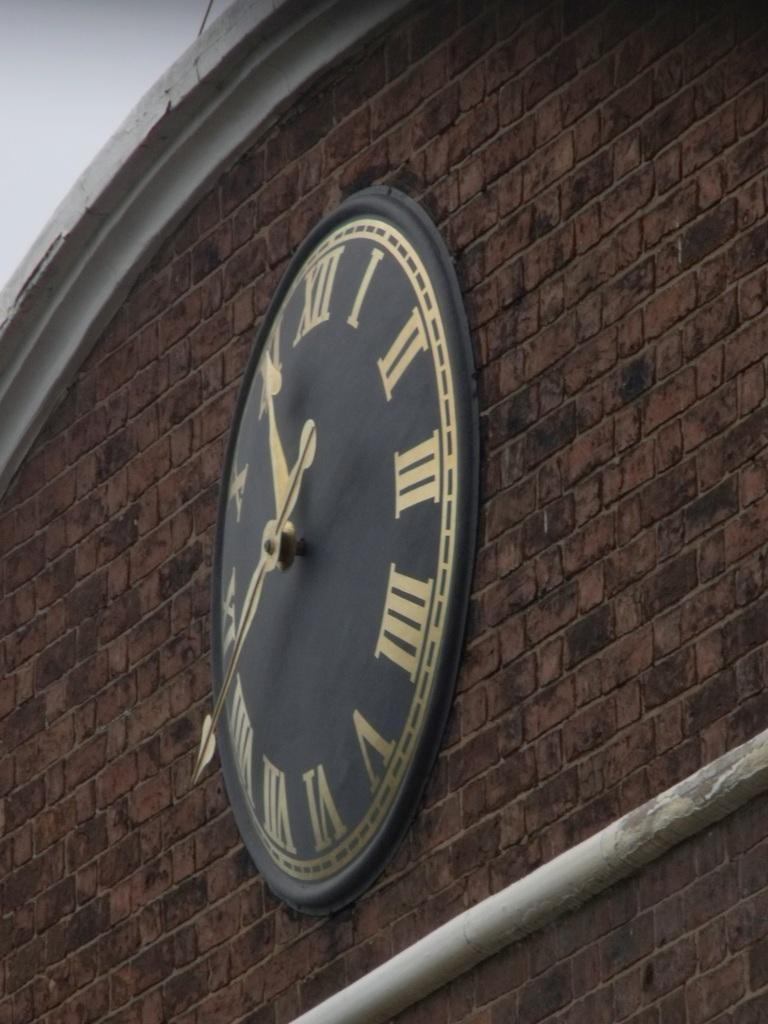<image>
Summarize the visual content of the image. A clock on a brick wall shows a time of approximately 11:40. 